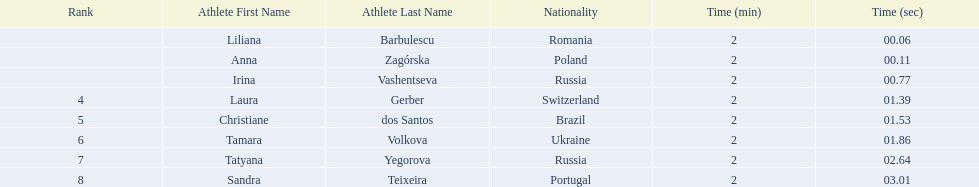What was the time difference between the first place finisher and the eighth place finisher? 2.95. 